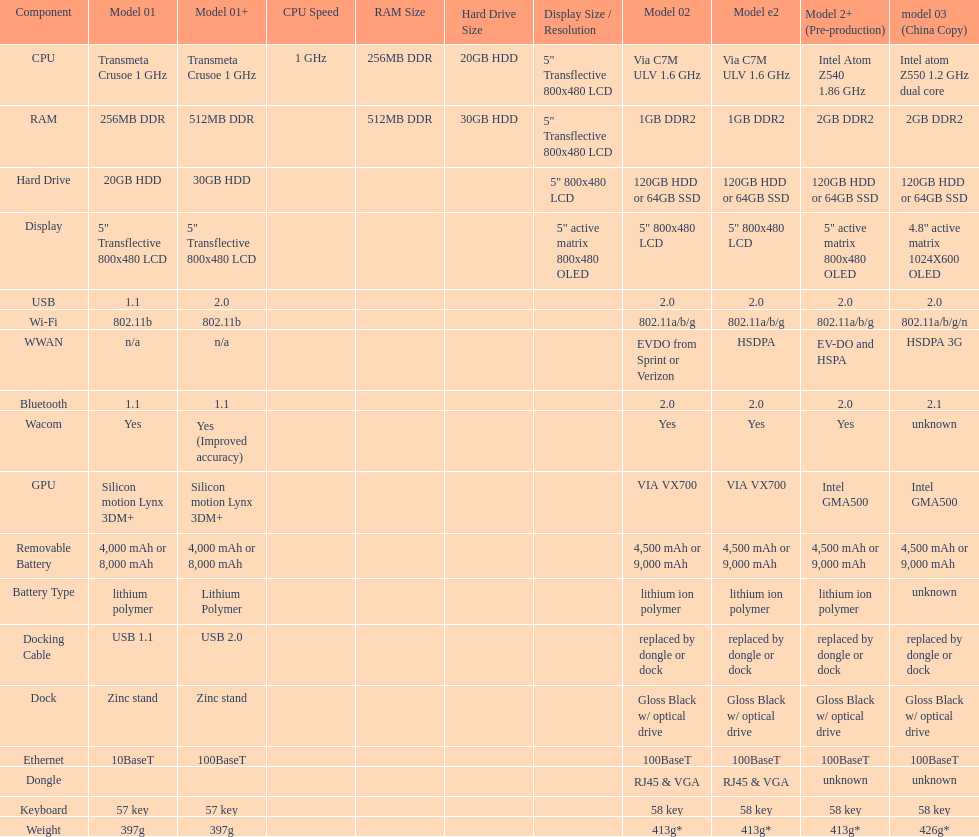Which model provides a larger hard drive: model 01 or model 02? Model 02. 